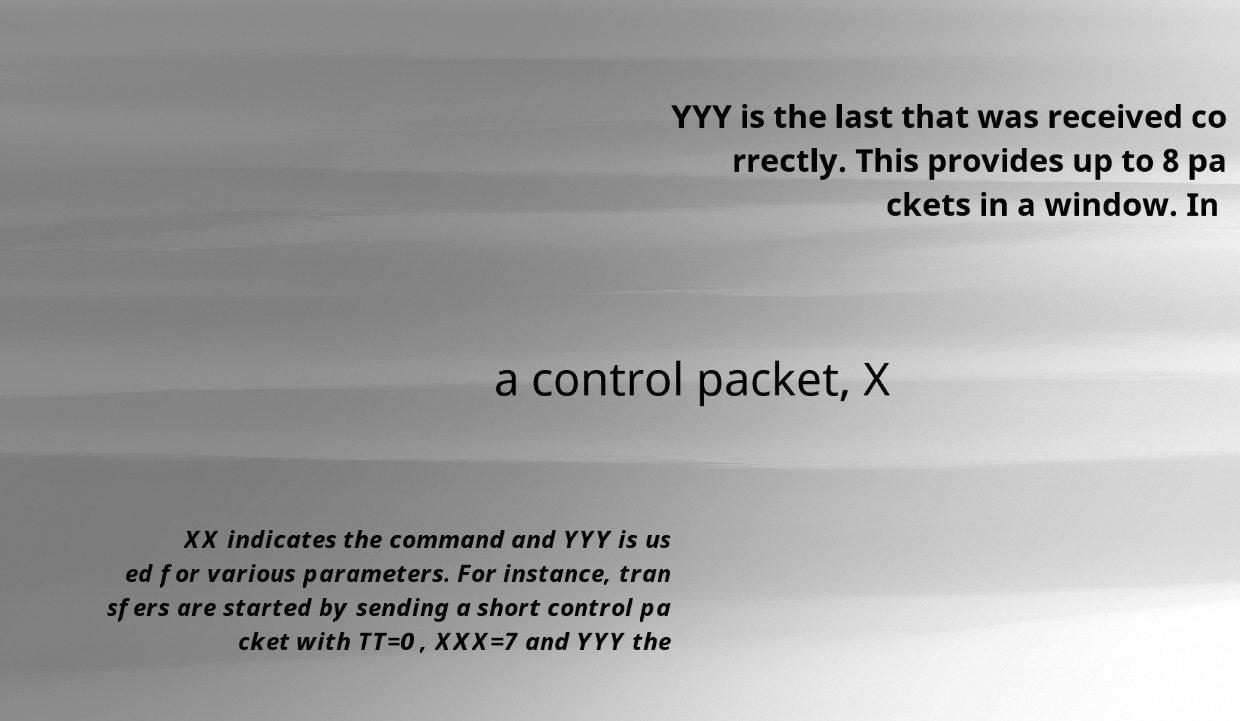For documentation purposes, I need the text within this image transcribed. Could you provide that? YYY is the last that was received co rrectly. This provides up to 8 pa ckets in a window. In a control packet, X XX indicates the command and YYY is us ed for various parameters. For instance, tran sfers are started by sending a short control pa cket with TT=0 , XXX=7 and YYY the 